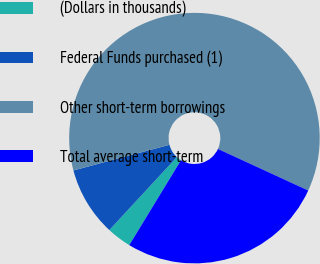<chart> <loc_0><loc_0><loc_500><loc_500><pie_chart><fcel>(Dollars in thousands)<fcel>Federal Funds purchased (1)<fcel>Other short-term borrowings<fcel>Total average short-term<nl><fcel>3.18%<fcel>8.96%<fcel>61.03%<fcel>26.84%<nl></chart> 